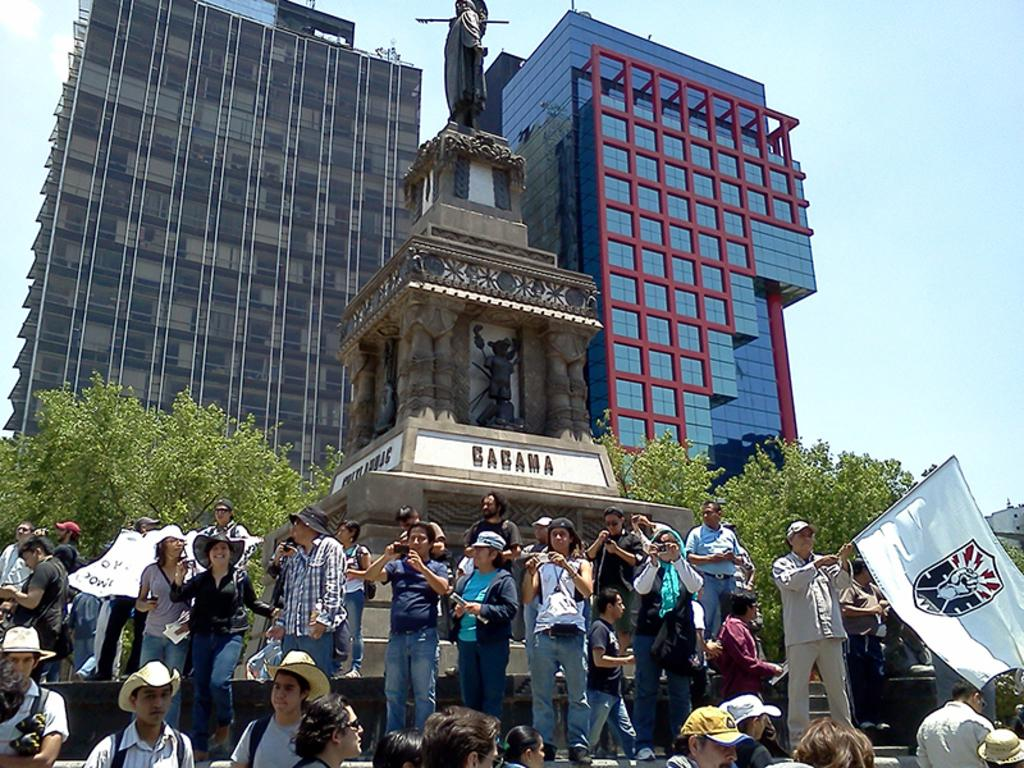What are the people in the image holding? The people in the image are holding objects, including flags, poles, and a statue. Can you describe the statue or another object with text? There is text on the statue or another object in the image. What type of structures can be seen in the image? There are buildings visible in the image. What other natural elements are present in the image? Trees are present in the image. What is visible in the background of the image? The sky is visible in the image. What type of poisonous cave can be seen in the image? There is no cave present in the image, let alone a poisonous one. 